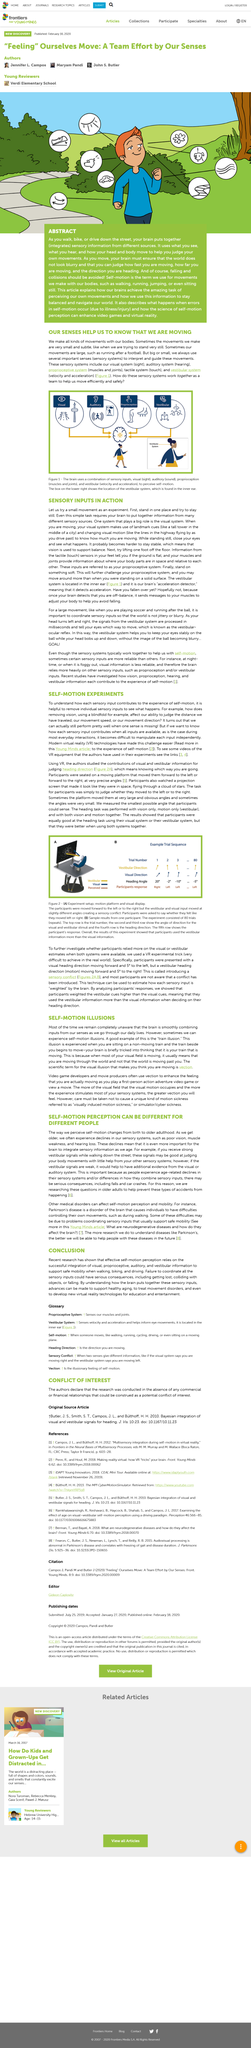Draw attention to some important aspects in this diagram. Sensory experiments can be made easier by utilizing virtual reality technology, which provides a simulated environment for research and experimentation. The projection screen in the experiment resembled space, appearing as if the participants were traveling through stars. Receiving strong vestibular signals is crucial when working as it enables an individual to accurately perceive and respond to their body movements. Parkinson's disease can cause difficulty with coordinating sensory inputs related to vision, muscle weakness, and hearing loss. Parkinson's disease is a disorder of the brain that affects movement. 